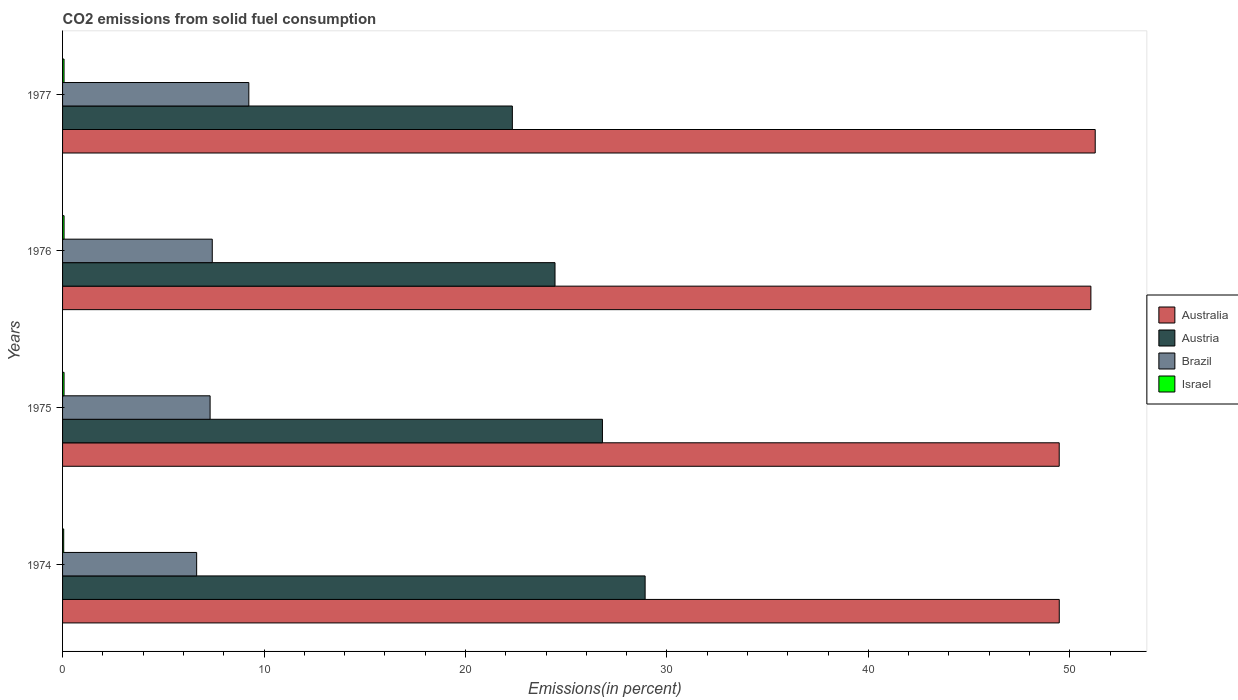Are the number of bars on each tick of the Y-axis equal?
Your response must be concise. Yes. How many bars are there on the 3rd tick from the bottom?
Make the answer very short. 4. What is the label of the 2nd group of bars from the top?
Your answer should be very brief. 1976. What is the total CO2 emitted in Israel in 1977?
Your answer should be compact. 0.07. Across all years, what is the maximum total CO2 emitted in Brazil?
Give a very brief answer. 9.25. Across all years, what is the minimum total CO2 emitted in Israel?
Keep it short and to the point. 0.06. In which year was the total CO2 emitted in Israel maximum?
Keep it short and to the point. 1976. In which year was the total CO2 emitted in Brazil minimum?
Ensure brevity in your answer.  1974. What is the total total CO2 emitted in Australia in the graph?
Provide a short and direct response. 201.25. What is the difference between the total CO2 emitted in Israel in 1974 and that in 1976?
Offer a very short reply. -0.02. What is the difference between the total CO2 emitted in Israel in 1977 and the total CO2 emitted in Australia in 1976?
Keep it short and to the point. -50.97. What is the average total CO2 emitted in Brazil per year?
Your answer should be very brief. 7.66. In the year 1974, what is the difference between the total CO2 emitted in Brazil and total CO2 emitted in Australia?
Offer a very short reply. -42.82. In how many years, is the total CO2 emitted in Brazil greater than 40 %?
Ensure brevity in your answer.  0. What is the ratio of the total CO2 emitted in Austria in 1974 to that in 1975?
Give a very brief answer. 1.08. What is the difference between the highest and the second highest total CO2 emitted in Brazil?
Provide a succinct answer. 1.82. What is the difference between the highest and the lowest total CO2 emitted in Israel?
Offer a very short reply. 0.02. What does the 4th bar from the top in 1975 represents?
Keep it short and to the point. Australia. Is it the case that in every year, the sum of the total CO2 emitted in Australia and total CO2 emitted in Austria is greater than the total CO2 emitted in Israel?
Make the answer very short. Yes. How many bars are there?
Your answer should be compact. 16. Are all the bars in the graph horizontal?
Keep it short and to the point. Yes. What is the difference between two consecutive major ticks on the X-axis?
Offer a terse response. 10. Are the values on the major ticks of X-axis written in scientific E-notation?
Provide a succinct answer. No. How many legend labels are there?
Offer a very short reply. 4. What is the title of the graph?
Provide a succinct answer. CO2 emissions from solid fuel consumption. Does "West Bank and Gaza" appear as one of the legend labels in the graph?
Offer a very short reply. No. What is the label or title of the X-axis?
Give a very brief answer. Emissions(in percent). What is the Emissions(in percent) in Australia in 1974?
Offer a very short reply. 49.47. What is the Emissions(in percent) of Austria in 1974?
Your answer should be compact. 28.92. What is the Emissions(in percent) of Brazil in 1974?
Offer a terse response. 6.66. What is the Emissions(in percent) in Israel in 1974?
Offer a very short reply. 0.06. What is the Emissions(in percent) in Australia in 1975?
Provide a succinct answer. 49.47. What is the Emissions(in percent) in Austria in 1975?
Provide a short and direct response. 26.8. What is the Emissions(in percent) in Brazil in 1975?
Provide a short and direct response. 7.32. What is the Emissions(in percent) of Israel in 1975?
Your answer should be compact. 0.07. What is the Emissions(in percent) in Australia in 1976?
Your response must be concise. 51.04. What is the Emissions(in percent) of Austria in 1976?
Make the answer very short. 24.44. What is the Emissions(in percent) in Brazil in 1976?
Provide a succinct answer. 7.43. What is the Emissions(in percent) in Israel in 1976?
Make the answer very short. 0.07. What is the Emissions(in percent) of Australia in 1977?
Your answer should be compact. 51.26. What is the Emissions(in percent) in Austria in 1977?
Provide a short and direct response. 22.33. What is the Emissions(in percent) in Brazil in 1977?
Give a very brief answer. 9.25. What is the Emissions(in percent) in Israel in 1977?
Offer a very short reply. 0.07. Across all years, what is the maximum Emissions(in percent) of Australia?
Offer a terse response. 51.26. Across all years, what is the maximum Emissions(in percent) in Austria?
Keep it short and to the point. 28.92. Across all years, what is the maximum Emissions(in percent) of Brazil?
Provide a succinct answer. 9.25. Across all years, what is the maximum Emissions(in percent) in Israel?
Provide a short and direct response. 0.07. Across all years, what is the minimum Emissions(in percent) of Australia?
Offer a terse response. 49.47. Across all years, what is the minimum Emissions(in percent) in Austria?
Your response must be concise. 22.33. Across all years, what is the minimum Emissions(in percent) in Brazil?
Offer a terse response. 6.66. Across all years, what is the minimum Emissions(in percent) of Israel?
Provide a succinct answer. 0.06. What is the total Emissions(in percent) in Australia in the graph?
Offer a terse response. 201.25. What is the total Emissions(in percent) in Austria in the graph?
Make the answer very short. 102.49. What is the total Emissions(in percent) in Brazil in the graph?
Provide a succinct answer. 30.66. What is the total Emissions(in percent) in Israel in the graph?
Your response must be concise. 0.28. What is the difference between the Emissions(in percent) of Australia in 1974 and that in 1975?
Your answer should be very brief. 0. What is the difference between the Emissions(in percent) in Austria in 1974 and that in 1975?
Provide a short and direct response. 2.12. What is the difference between the Emissions(in percent) in Brazil in 1974 and that in 1975?
Your response must be concise. -0.67. What is the difference between the Emissions(in percent) in Israel in 1974 and that in 1975?
Your answer should be very brief. -0.02. What is the difference between the Emissions(in percent) in Australia in 1974 and that in 1976?
Give a very brief answer. -1.57. What is the difference between the Emissions(in percent) of Austria in 1974 and that in 1976?
Offer a very short reply. 4.47. What is the difference between the Emissions(in percent) in Brazil in 1974 and that in 1976?
Offer a very short reply. -0.77. What is the difference between the Emissions(in percent) of Israel in 1974 and that in 1976?
Your answer should be compact. -0.02. What is the difference between the Emissions(in percent) in Australia in 1974 and that in 1977?
Offer a very short reply. -1.78. What is the difference between the Emissions(in percent) in Austria in 1974 and that in 1977?
Your response must be concise. 6.59. What is the difference between the Emissions(in percent) of Brazil in 1974 and that in 1977?
Your response must be concise. -2.59. What is the difference between the Emissions(in percent) of Israel in 1974 and that in 1977?
Ensure brevity in your answer.  -0.02. What is the difference between the Emissions(in percent) in Australia in 1975 and that in 1976?
Ensure brevity in your answer.  -1.57. What is the difference between the Emissions(in percent) of Austria in 1975 and that in 1976?
Your response must be concise. 2.35. What is the difference between the Emissions(in percent) of Brazil in 1975 and that in 1976?
Your answer should be very brief. -0.11. What is the difference between the Emissions(in percent) of Israel in 1975 and that in 1976?
Provide a succinct answer. -0. What is the difference between the Emissions(in percent) of Australia in 1975 and that in 1977?
Your response must be concise. -1.79. What is the difference between the Emissions(in percent) of Austria in 1975 and that in 1977?
Give a very brief answer. 4.47. What is the difference between the Emissions(in percent) of Brazil in 1975 and that in 1977?
Make the answer very short. -1.92. What is the difference between the Emissions(in percent) of Israel in 1975 and that in 1977?
Your answer should be very brief. 0. What is the difference between the Emissions(in percent) of Australia in 1976 and that in 1977?
Ensure brevity in your answer.  -0.21. What is the difference between the Emissions(in percent) of Austria in 1976 and that in 1977?
Keep it short and to the point. 2.12. What is the difference between the Emissions(in percent) in Brazil in 1976 and that in 1977?
Ensure brevity in your answer.  -1.82. What is the difference between the Emissions(in percent) of Israel in 1976 and that in 1977?
Offer a terse response. 0. What is the difference between the Emissions(in percent) of Australia in 1974 and the Emissions(in percent) of Austria in 1975?
Make the answer very short. 22.68. What is the difference between the Emissions(in percent) in Australia in 1974 and the Emissions(in percent) in Brazil in 1975?
Keep it short and to the point. 42.15. What is the difference between the Emissions(in percent) in Australia in 1974 and the Emissions(in percent) in Israel in 1975?
Make the answer very short. 49.4. What is the difference between the Emissions(in percent) in Austria in 1974 and the Emissions(in percent) in Brazil in 1975?
Offer a very short reply. 21.59. What is the difference between the Emissions(in percent) in Austria in 1974 and the Emissions(in percent) in Israel in 1975?
Your answer should be very brief. 28.84. What is the difference between the Emissions(in percent) in Brazil in 1974 and the Emissions(in percent) in Israel in 1975?
Give a very brief answer. 6.58. What is the difference between the Emissions(in percent) of Australia in 1974 and the Emissions(in percent) of Austria in 1976?
Give a very brief answer. 25.03. What is the difference between the Emissions(in percent) in Australia in 1974 and the Emissions(in percent) in Brazil in 1976?
Keep it short and to the point. 42.04. What is the difference between the Emissions(in percent) in Australia in 1974 and the Emissions(in percent) in Israel in 1976?
Provide a succinct answer. 49.4. What is the difference between the Emissions(in percent) in Austria in 1974 and the Emissions(in percent) in Brazil in 1976?
Offer a very short reply. 21.49. What is the difference between the Emissions(in percent) in Austria in 1974 and the Emissions(in percent) in Israel in 1976?
Offer a very short reply. 28.84. What is the difference between the Emissions(in percent) in Brazil in 1974 and the Emissions(in percent) in Israel in 1976?
Provide a short and direct response. 6.58. What is the difference between the Emissions(in percent) in Australia in 1974 and the Emissions(in percent) in Austria in 1977?
Your answer should be very brief. 27.15. What is the difference between the Emissions(in percent) of Australia in 1974 and the Emissions(in percent) of Brazil in 1977?
Make the answer very short. 40.23. What is the difference between the Emissions(in percent) of Australia in 1974 and the Emissions(in percent) of Israel in 1977?
Your answer should be very brief. 49.4. What is the difference between the Emissions(in percent) in Austria in 1974 and the Emissions(in percent) in Brazil in 1977?
Offer a terse response. 19.67. What is the difference between the Emissions(in percent) of Austria in 1974 and the Emissions(in percent) of Israel in 1977?
Your answer should be compact. 28.84. What is the difference between the Emissions(in percent) of Brazil in 1974 and the Emissions(in percent) of Israel in 1977?
Offer a very short reply. 6.58. What is the difference between the Emissions(in percent) in Australia in 1975 and the Emissions(in percent) in Austria in 1976?
Make the answer very short. 25.03. What is the difference between the Emissions(in percent) of Australia in 1975 and the Emissions(in percent) of Brazil in 1976?
Ensure brevity in your answer.  42.04. What is the difference between the Emissions(in percent) in Australia in 1975 and the Emissions(in percent) in Israel in 1976?
Make the answer very short. 49.4. What is the difference between the Emissions(in percent) of Austria in 1975 and the Emissions(in percent) of Brazil in 1976?
Provide a short and direct response. 19.37. What is the difference between the Emissions(in percent) in Austria in 1975 and the Emissions(in percent) in Israel in 1976?
Your response must be concise. 26.72. What is the difference between the Emissions(in percent) in Brazil in 1975 and the Emissions(in percent) in Israel in 1976?
Your response must be concise. 7.25. What is the difference between the Emissions(in percent) in Australia in 1975 and the Emissions(in percent) in Austria in 1977?
Your answer should be compact. 27.15. What is the difference between the Emissions(in percent) in Australia in 1975 and the Emissions(in percent) in Brazil in 1977?
Your response must be concise. 40.23. What is the difference between the Emissions(in percent) in Australia in 1975 and the Emissions(in percent) in Israel in 1977?
Ensure brevity in your answer.  49.4. What is the difference between the Emissions(in percent) in Austria in 1975 and the Emissions(in percent) in Brazil in 1977?
Your response must be concise. 17.55. What is the difference between the Emissions(in percent) in Austria in 1975 and the Emissions(in percent) in Israel in 1977?
Keep it short and to the point. 26.72. What is the difference between the Emissions(in percent) in Brazil in 1975 and the Emissions(in percent) in Israel in 1977?
Ensure brevity in your answer.  7.25. What is the difference between the Emissions(in percent) in Australia in 1976 and the Emissions(in percent) in Austria in 1977?
Give a very brief answer. 28.72. What is the difference between the Emissions(in percent) in Australia in 1976 and the Emissions(in percent) in Brazil in 1977?
Keep it short and to the point. 41.8. What is the difference between the Emissions(in percent) in Australia in 1976 and the Emissions(in percent) in Israel in 1977?
Your answer should be compact. 50.97. What is the difference between the Emissions(in percent) of Austria in 1976 and the Emissions(in percent) of Brazil in 1977?
Offer a terse response. 15.2. What is the difference between the Emissions(in percent) of Austria in 1976 and the Emissions(in percent) of Israel in 1977?
Ensure brevity in your answer.  24.37. What is the difference between the Emissions(in percent) in Brazil in 1976 and the Emissions(in percent) in Israel in 1977?
Keep it short and to the point. 7.36. What is the average Emissions(in percent) in Australia per year?
Give a very brief answer. 50.31. What is the average Emissions(in percent) in Austria per year?
Keep it short and to the point. 25.62. What is the average Emissions(in percent) of Brazil per year?
Provide a succinct answer. 7.66. What is the average Emissions(in percent) of Israel per year?
Provide a short and direct response. 0.07. In the year 1974, what is the difference between the Emissions(in percent) in Australia and Emissions(in percent) in Austria?
Your answer should be very brief. 20.56. In the year 1974, what is the difference between the Emissions(in percent) in Australia and Emissions(in percent) in Brazil?
Keep it short and to the point. 42.82. In the year 1974, what is the difference between the Emissions(in percent) of Australia and Emissions(in percent) of Israel?
Ensure brevity in your answer.  49.42. In the year 1974, what is the difference between the Emissions(in percent) of Austria and Emissions(in percent) of Brazil?
Provide a short and direct response. 22.26. In the year 1974, what is the difference between the Emissions(in percent) in Austria and Emissions(in percent) in Israel?
Offer a very short reply. 28.86. In the year 1974, what is the difference between the Emissions(in percent) of Brazil and Emissions(in percent) of Israel?
Make the answer very short. 6.6. In the year 1975, what is the difference between the Emissions(in percent) in Australia and Emissions(in percent) in Austria?
Provide a short and direct response. 22.67. In the year 1975, what is the difference between the Emissions(in percent) in Australia and Emissions(in percent) in Brazil?
Ensure brevity in your answer.  42.15. In the year 1975, what is the difference between the Emissions(in percent) in Australia and Emissions(in percent) in Israel?
Provide a succinct answer. 49.4. In the year 1975, what is the difference between the Emissions(in percent) in Austria and Emissions(in percent) in Brazil?
Provide a short and direct response. 19.47. In the year 1975, what is the difference between the Emissions(in percent) in Austria and Emissions(in percent) in Israel?
Keep it short and to the point. 26.72. In the year 1975, what is the difference between the Emissions(in percent) in Brazil and Emissions(in percent) in Israel?
Keep it short and to the point. 7.25. In the year 1976, what is the difference between the Emissions(in percent) of Australia and Emissions(in percent) of Austria?
Offer a very short reply. 26.6. In the year 1976, what is the difference between the Emissions(in percent) in Australia and Emissions(in percent) in Brazil?
Make the answer very short. 43.61. In the year 1976, what is the difference between the Emissions(in percent) in Australia and Emissions(in percent) in Israel?
Provide a short and direct response. 50.97. In the year 1976, what is the difference between the Emissions(in percent) of Austria and Emissions(in percent) of Brazil?
Make the answer very short. 17.01. In the year 1976, what is the difference between the Emissions(in percent) of Austria and Emissions(in percent) of Israel?
Your answer should be very brief. 24.37. In the year 1976, what is the difference between the Emissions(in percent) of Brazil and Emissions(in percent) of Israel?
Keep it short and to the point. 7.36. In the year 1977, what is the difference between the Emissions(in percent) of Australia and Emissions(in percent) of Austria?
Keep it short and to the point. 28.93. In the year 1977, what is the difference between the Emissions(in percent) in Australia and Emissions(in percent) in Brazil?
Offer a terse response. 42.01. In the year 1977, what is the difference between the Emissions(in percent) in Australia and Emissions(in percent) in Israel?
Offer a terse response. 51.19. In the year 1977, what is the difference between the Emissions(in percent) in Austria and Emissions(in percent) in Brazil?
Offer a very short reply. 13.08. In the year 1977, what is the difference between the Emissions(in percent) in Austria and Emissions(in percent) in Israel?
Offer a very short reply. 22.25. In the year 1977, what is the difference between the Emissions(in percent) of Brazil and Emissions(in percent) of Israel?
Offer a very short reply. 9.17. What is the ratio of the Emissions(in percent) in Austria in 1974 to that in 1975?
Provide a succinct answer. 1.08. What is the ratio of the Emissions(in percent) in Brazil in 1974 to that in 1975?
Offer a very short reply. 0.91. What is the ratio of the Emissions(in percent) of Israel in 1974 to that in 1975?
Offer a terse response. 0.76. What is the ratio of the Emissions(in percent) in Australia in 1974 to that in 1976?
Provide a short and direct response. 0.97. What is the ratio of the Emissions(in percent) in Austria in 1974 to that in 1976?
Your answer should be very brief. 1.18. What is the ratio of the Emissions(in percent) in Brazil in 1974 to that in 1976?
Offer a very short reply. 0.9. What is the ratio of the Emissions(in percent) in Israel in 1974 to that in 1976?
Provide a short and direct response. 0.76. What is the ratio of the Emissions(in percent) in Australia in 1974 to that in 1977?
Make the answer very short. 0.97. What is the ratio of the Emissions(in percent) in Austria in 1974 to that in 1977?
Offer a terse response. 1.3. What is the ratio of the Emissions(in percent) of Brazil in 1974 to that in 1977?
Your answer should be compact. 0.72. What is the ratio of the Emissions(in percent) of Israel in 1974 to that in 1977?
Offer a very short reply. 0.77. What is the ratio of the Emissions(in percent) of Australia in 1975 to that in 1976?
Provide a short and direct response. 0.97. What is the ratio of the Emissions(in percent) of Austria in 1975 to that in 1976?
Make the answer very short. 1.1. What is the ratio of the Emissions(in percent) of Brazil in 1975 to that in 1976?
Make the answer very short. 0.99. What is the ratio of the Emissions(in percent) in Israel in 1975 to that in 1976?
Provide a short and direct response. 1. What is the ratio of the Emissions(in percent) in Australia in 1975 to that in 1977?
Offer a terse response. 0.97. What is the ratio of the Emissions(in percent) of Austria in 1975 to that in 1977?
Keep it short and to the point. 1.2. What is the ratio of the Emissions(in percent) in Brazil in 1975 to that in 1977?
Your answer should be compact. 0.79. What is the ratio of the Emissions(in percent) of Israel in 1975 to that in 1977?
Offer a very short reply. 1.01. What is the ratio of the Emissions(in percent) in Austria in 1976 to that in 1977?
Your answer should be compact. 1.09. What is the ratio of the Emissions(in percent) of Brazil in 1976 to that in 1977?
Make the answer very short. 0.8. What is the ratio of the Emissions(in percent) of Israel in 1976 to that in 1977?
Provide a succinct answer. 1.01. What is the difference between the highest and the second highest Emissions(in percent) in Australia?
Offer a very short reply. 0.21. What is the difference between the highest and the second highest Emissions(in percent) of Austria?
Offer a terse response. 2.12. What is the difference between the highest and the second highest Emissions(in percent) of Brazil?
Provide a short and direct response. 1.82. What is the difference between the highest and the second highest Emissions(in percent) in Israel?
Keep it short and to the point. 0. What is the difference between the highest and the lowest Emissions(in percent) in Australia?
Your response must be concise. 1.79. What is the difference between the highest and the lowest Emissions(in percent) in Austria?
Offer a terse response. 6.59. What is the difference between the highest and the lowest Emissions(in percent) of Brazil?
Give a very brief answer. 2.59. What is the difference between the highest and the lowest Emissions(in percent) of Israel?
Provide a succinct answer. 0.02. 